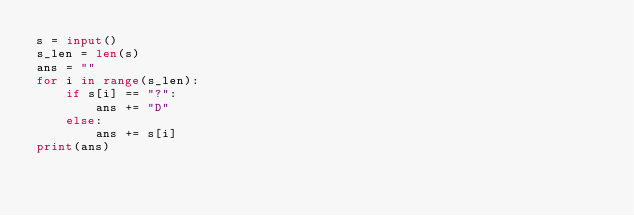Convert code to text. <code><loc_0><loc_0><loc_500><loc_500><_Python_>s = input()
s_len = len(s)
ans = ""
for i in range(s_len):
    if s[i] == "?":
        ans += "D"
    else:
        ans += s[i]
print(ans)
</code> 